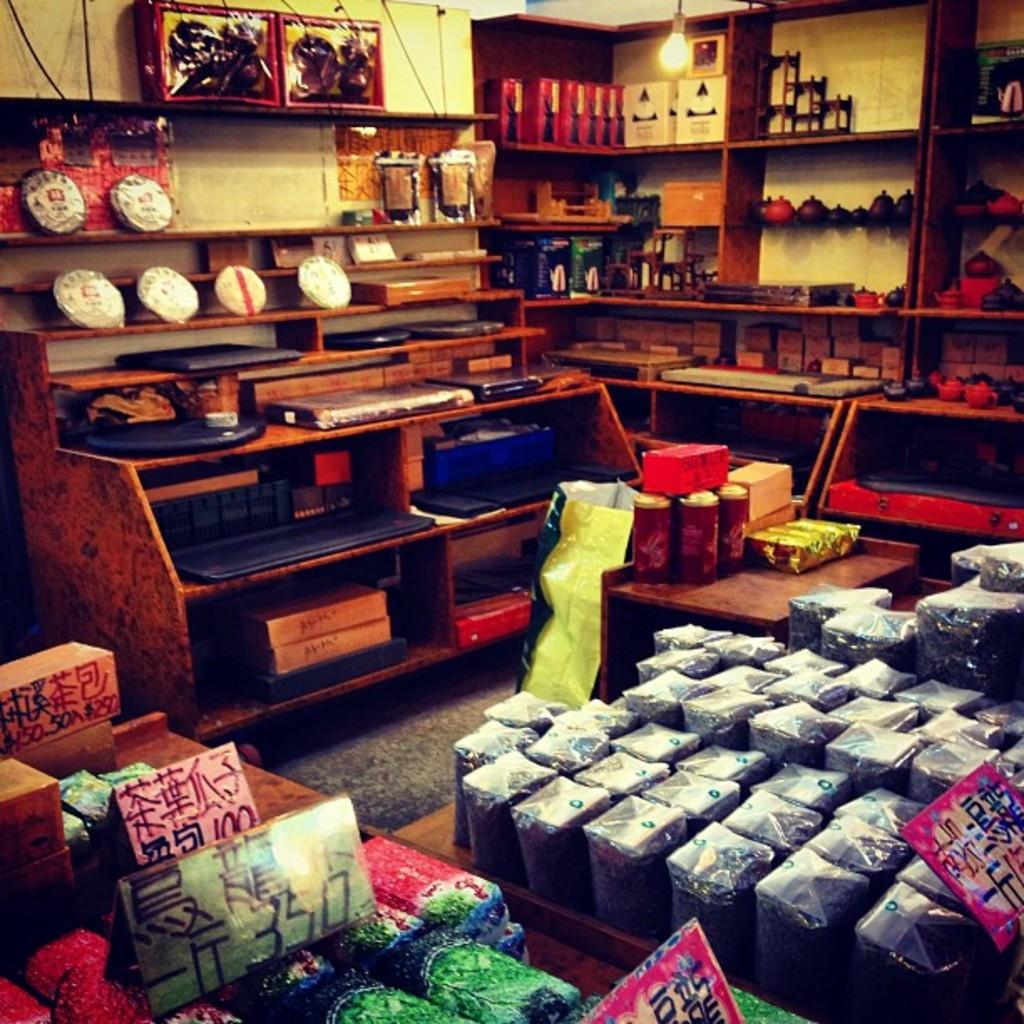<image>
Describe the image concisely. A storage area with boxes covered in Chinese writting and numbers. 